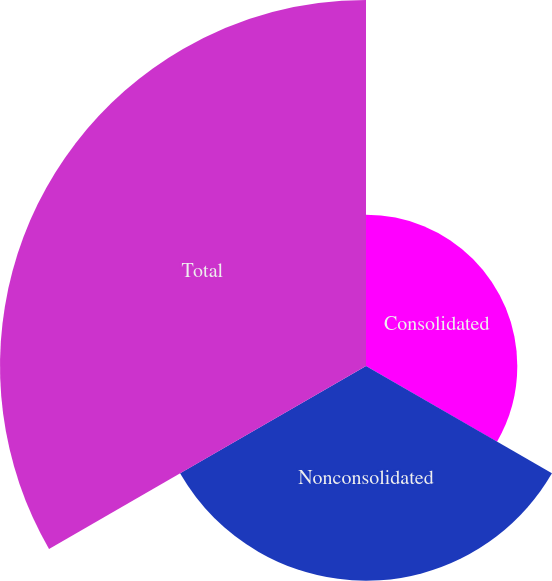<chart> <loc_0><loc_0><loc_500><loc_500><pie_chart><fcel>Consolidated<fcel>Nonconsolidated<fcel>Total<nl><fcel>20.67%<fcel>29.33%<fcel>50.0%<nl></chart> 